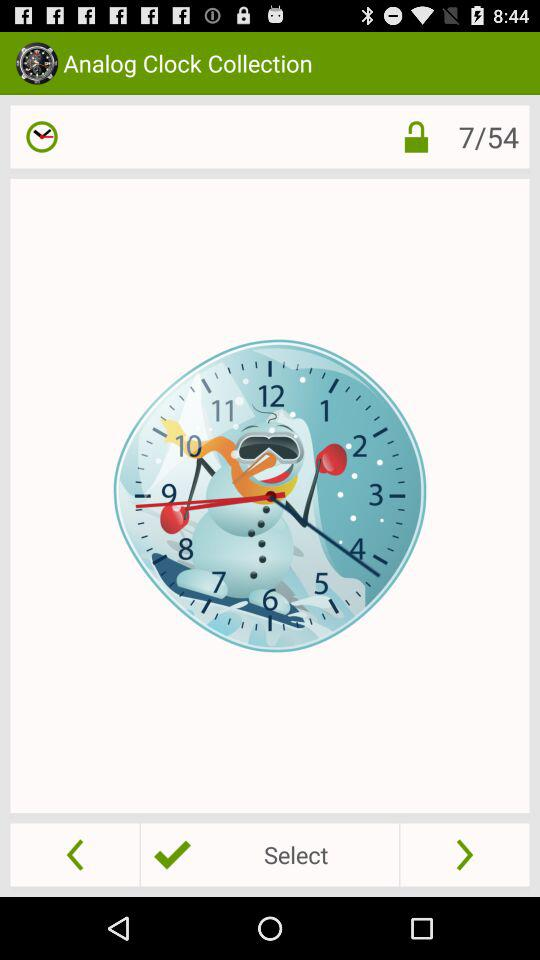What is the number of slides? The number of slides is 54. 